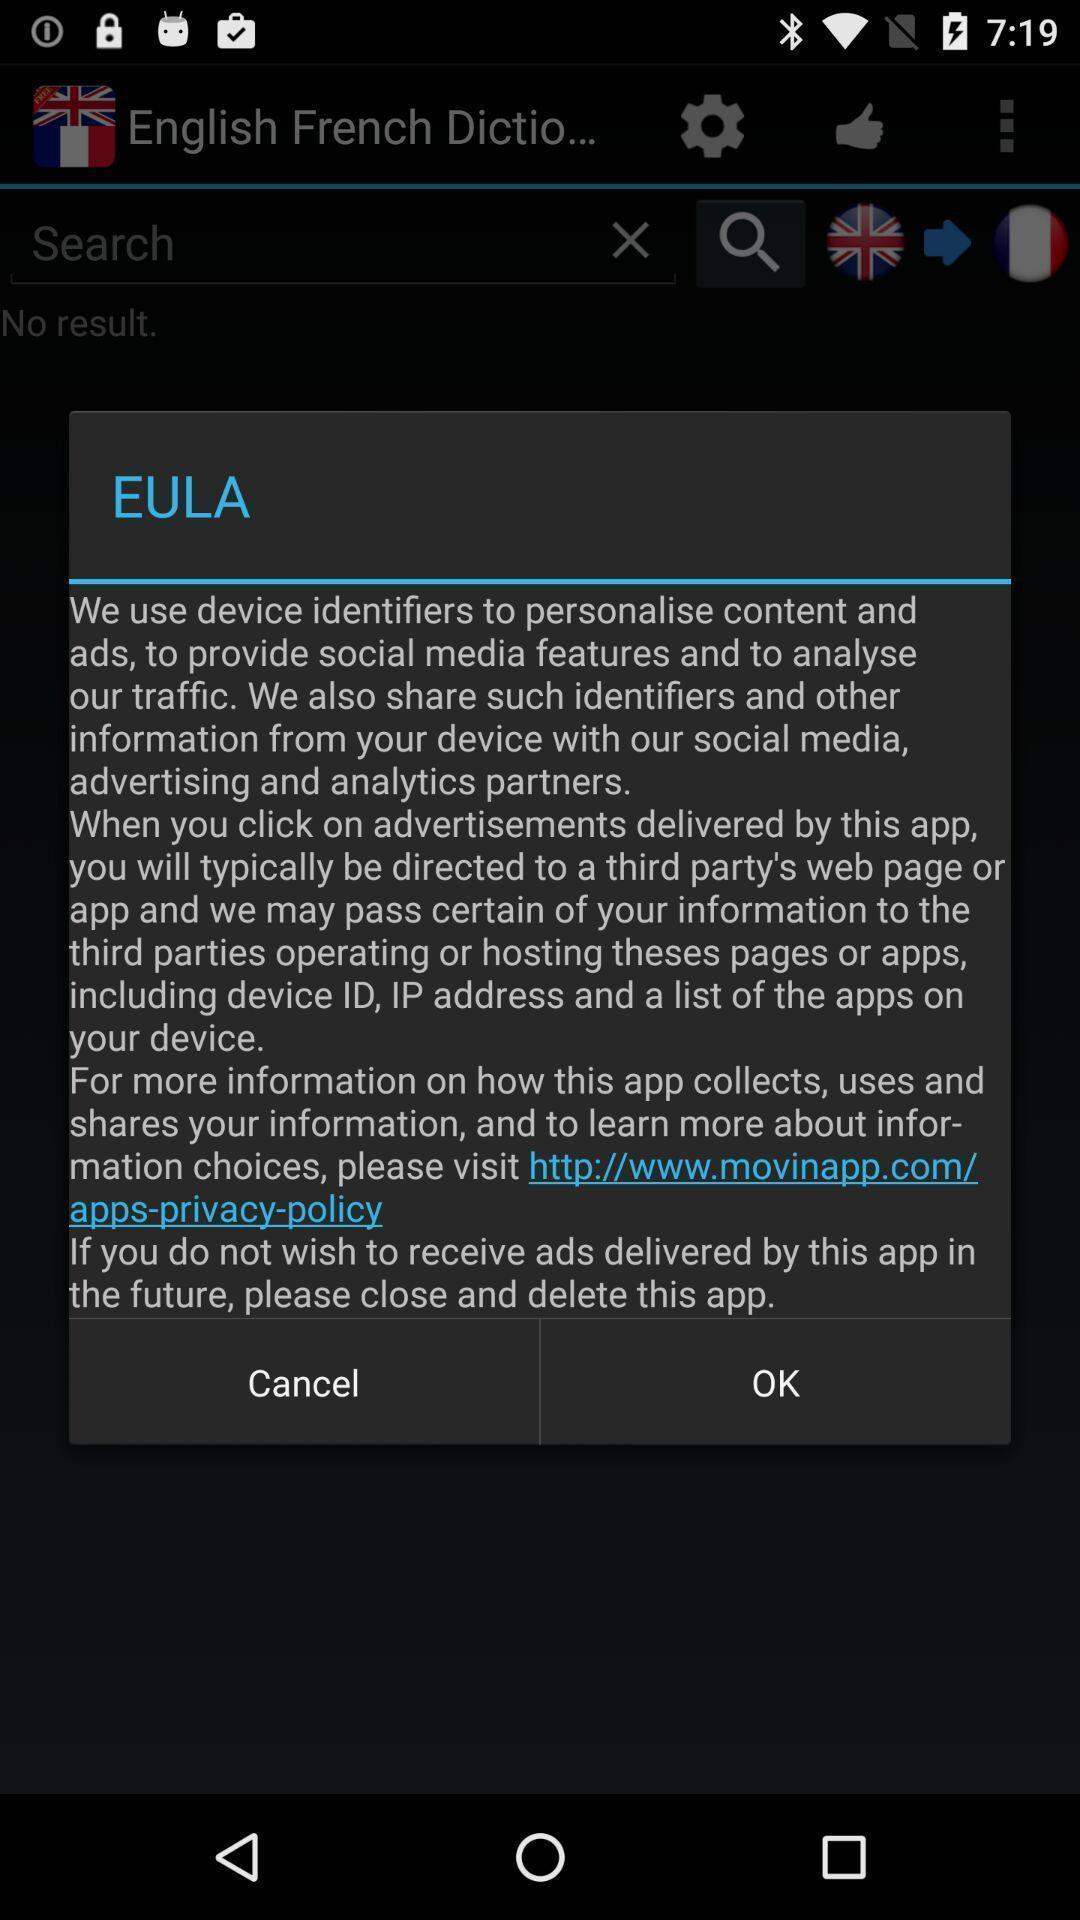Tell me about the visual elements in this screen capture. Pop-up showing information about the app. 